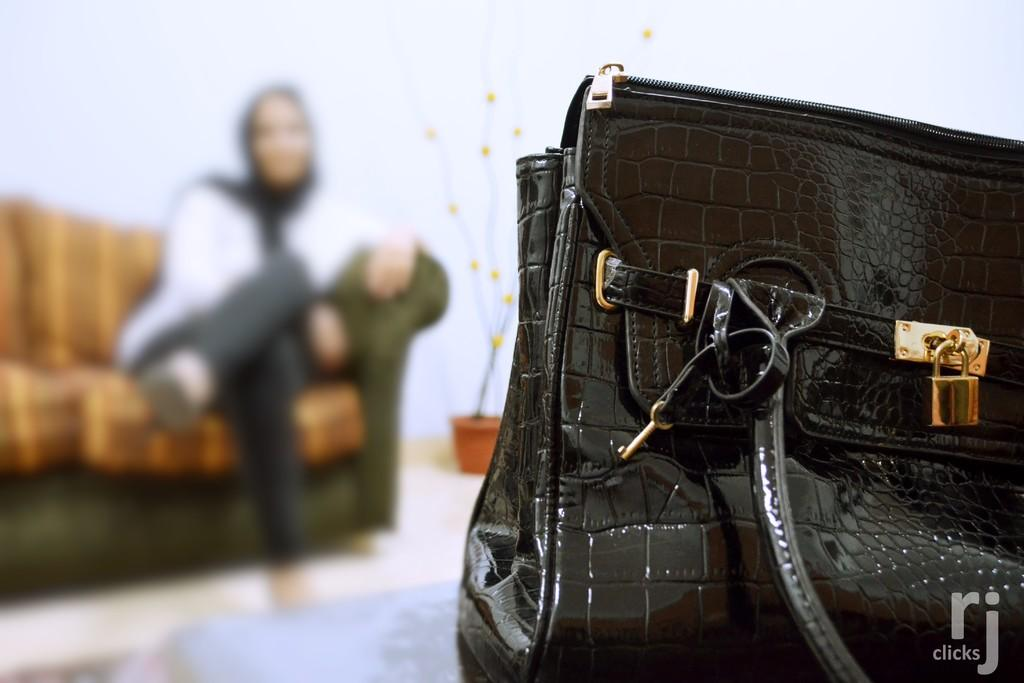What object is located on the right side of the image? There is a bag on the right side of the image. What is the color of the bag? The bag is black in color. Where is the person sitting in the image? The person is sitting on the couch on the left side of the image. What can be seen in the background of the image? There is a wall and a flower pot in the background of the image. What type of guitar is the person playing in the image? There is no guitar present in the image; the person is sitting on a couch. What texture can be seen on the pencil in the image? There is no pencil present in the image, so it is not possible to determine its texture. 